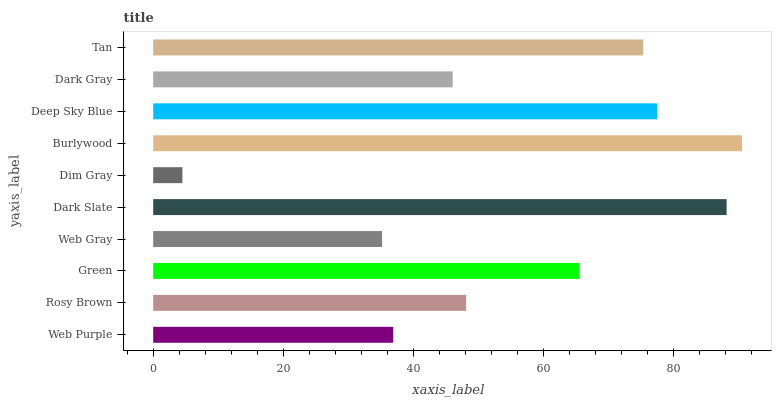Is Dim Gray the minimum?
Answer yes or no. Yes. Is Burlywood the maximum?
Answer yes or no. Yes. Is Rosy Brown the minimum?
Answer yes or no. No. Is Rosy Brown the maximum?
Answer yes or no. No. Is Rosy Brown greater than Web Purple?
Answer yes or no. Yes. Is Web Purple less than Rosy Brown?
Answer yes or no. Yes. Is Web Purple greater than Rosy Brown?
Answer yes or no. No. Is Rosy Brown less than Web Purple?
Answer yes or no. No. Is Green the high median?
Answer yes or no. Yes. Is Rosy Brown the low median?
Answer yes or no. Yes. Is Tan the high median?
Answer yes or no. No. Is Deep Sky Blue the low median?
Answer yes or no. No. 